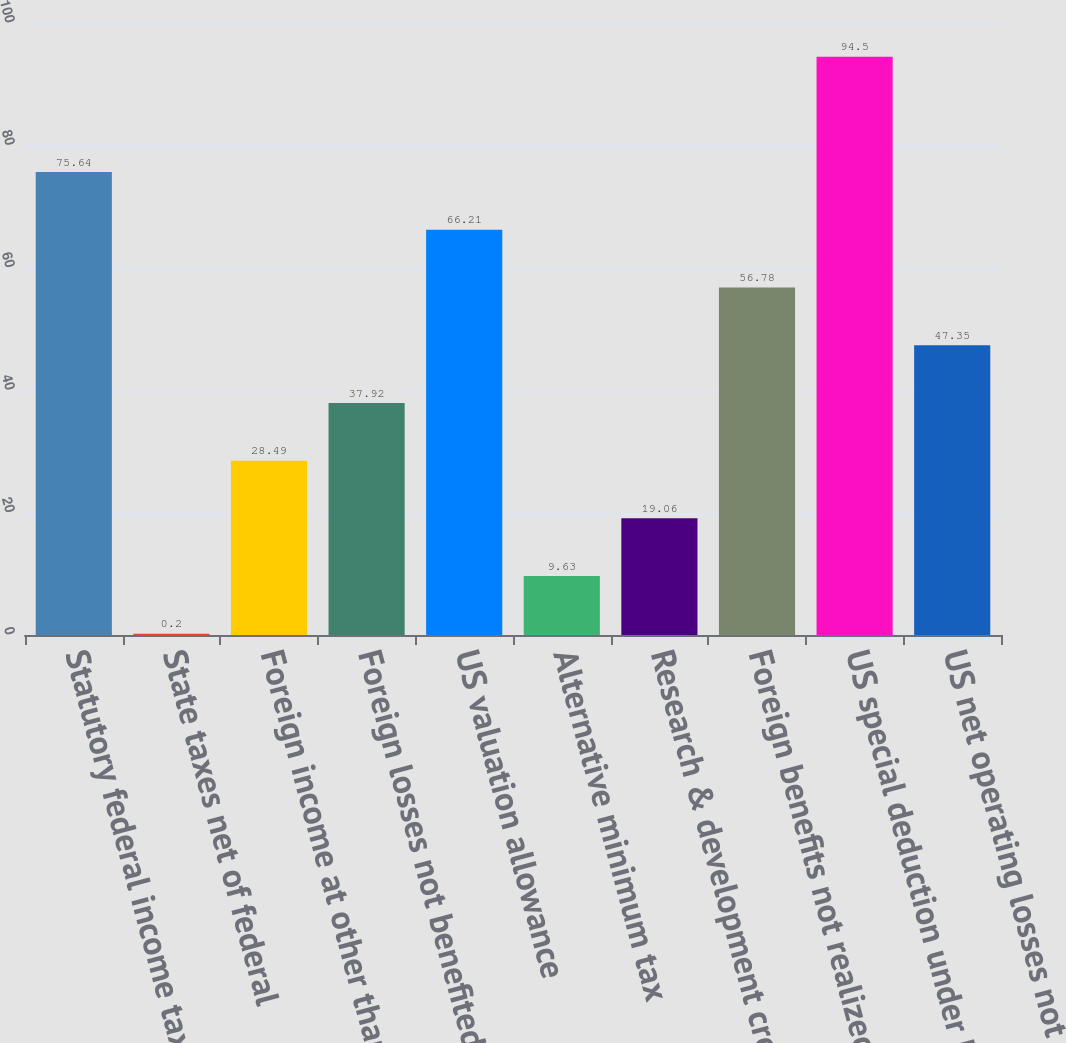Convert chart. <chart><loc_0><loc_0><loc_500><loc_500><bar_chart><fcel>Statutory federal income tax<fcel>State taxes net of federal<fcel>Foreign income at other than<fcel>Foreign losses not benefited<fcel>US valuation allowance<fcel>Alternative minimum tax<fcel>Research & development credit<fcel>Foreign benefits not realized<fcel>US special deduction under IRC<fcel>US net operating losses not<nl><fcel>75.64<fcel>0.2<fcel>28.49<fcel>37.92<fcel>66.21<fcel>9.63<fcel>19.06<fcel>56.78<fcel>94.5<fcel>47.35<nl></chart> 